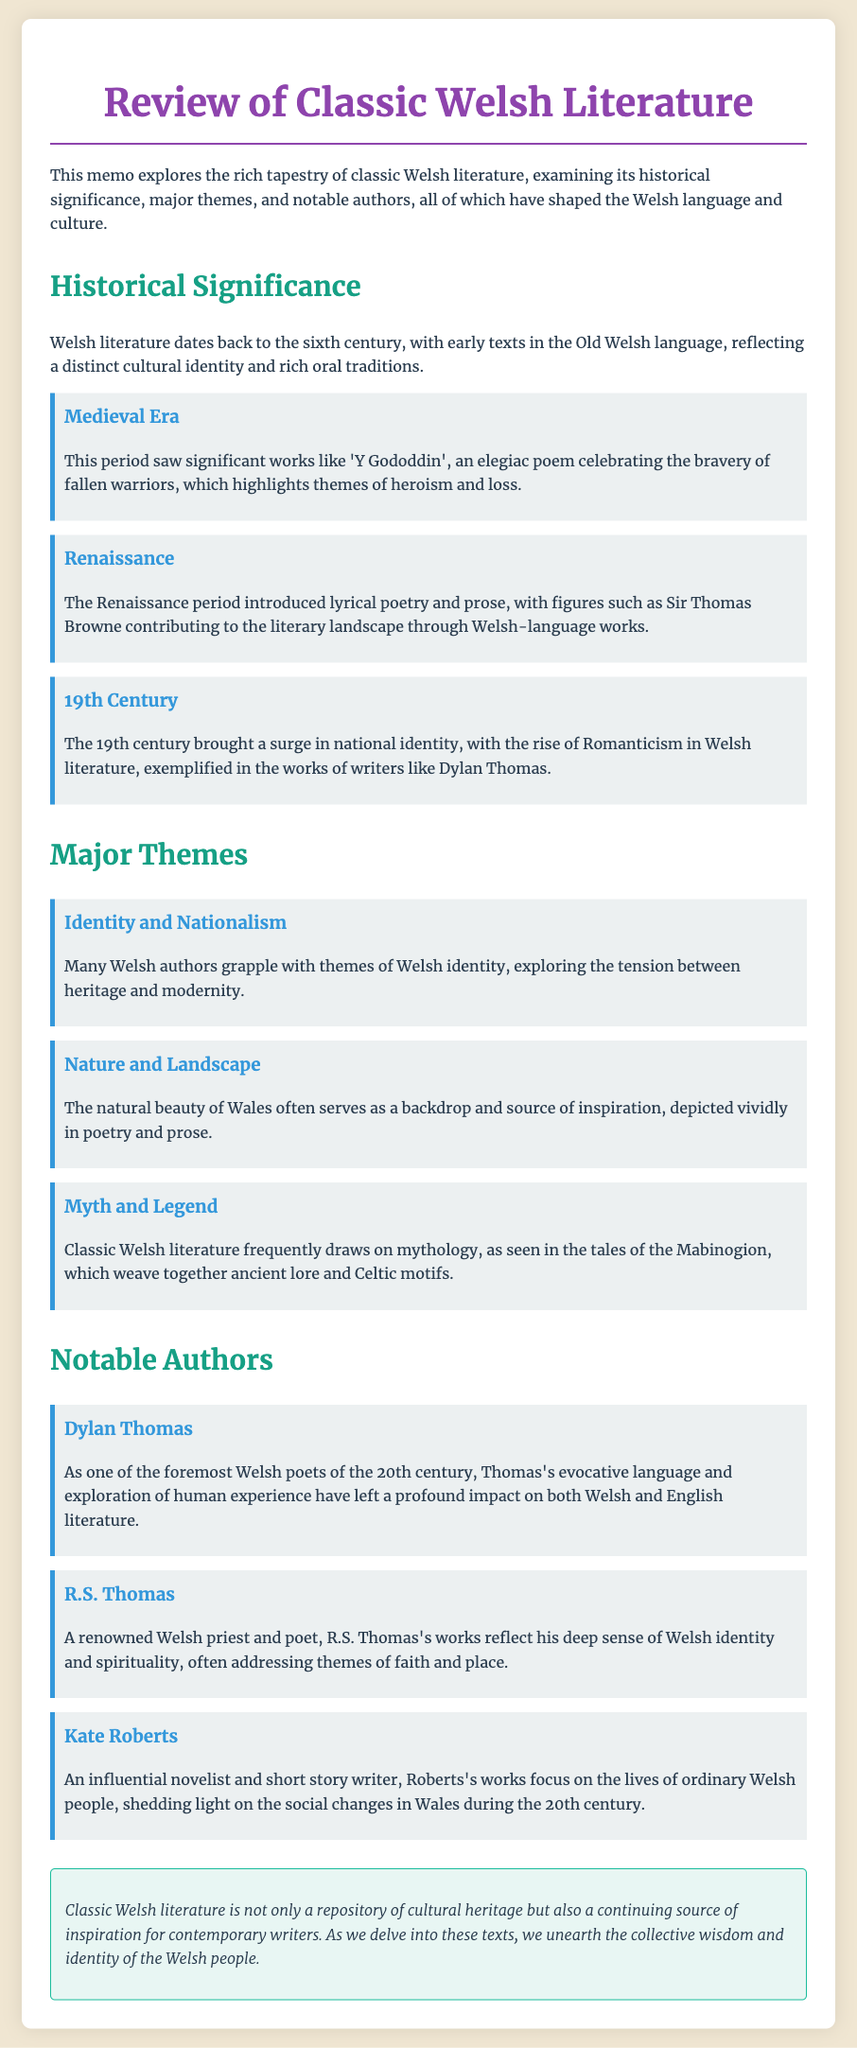What is the earliest period in Welsh literature mentioned? The earliest period mentioned in the document is the Medieval Era, which dates back to the sixth century.
Answer: Medieval Era Which notable work is associated with the Medieval Era? The document states that 'Y Gododdin' is a significant work from the Medieval Era.
Answer: Y Gododdin Who is considered one of the foremost Welsh poets of the 20th century? The document identifies Dylan Thomas as a foremost Welsh poet of the 20th century.
Answer: Dylan Thomas What theme explores the tension between heritage and modernity? Identity and Nationalism is the theme that discusses this tension in Welsh literature.
Answer: Identity and Nationalism Which author is known for addressing themes of faith and place? R.S. Thomas is known for his works reflecting themes of faith and place.
Answer: R.S. Thomas What significant literary movement arose in the 19th century? The 19th century saw the rise of Romanticism in Welsh literature.
Answer: Romanticism What work is referenced in relation to myth and legend? The Mabinogion is referenced in the context of mythology in Welsh literature.
Answer: The Mabinogion What characteristic is highlighted about Kate Roberts' works? Kate Roberts' works focus on the lives of ordinary Welsh people and social changes.
Answer: Ordinary Welsh people What overarching role does classic Welsh literature play in contemporary writing? Classic Welsh literature is described as a continuing source of inspiration for contemporary writers.
Answer: Source of inspiration 